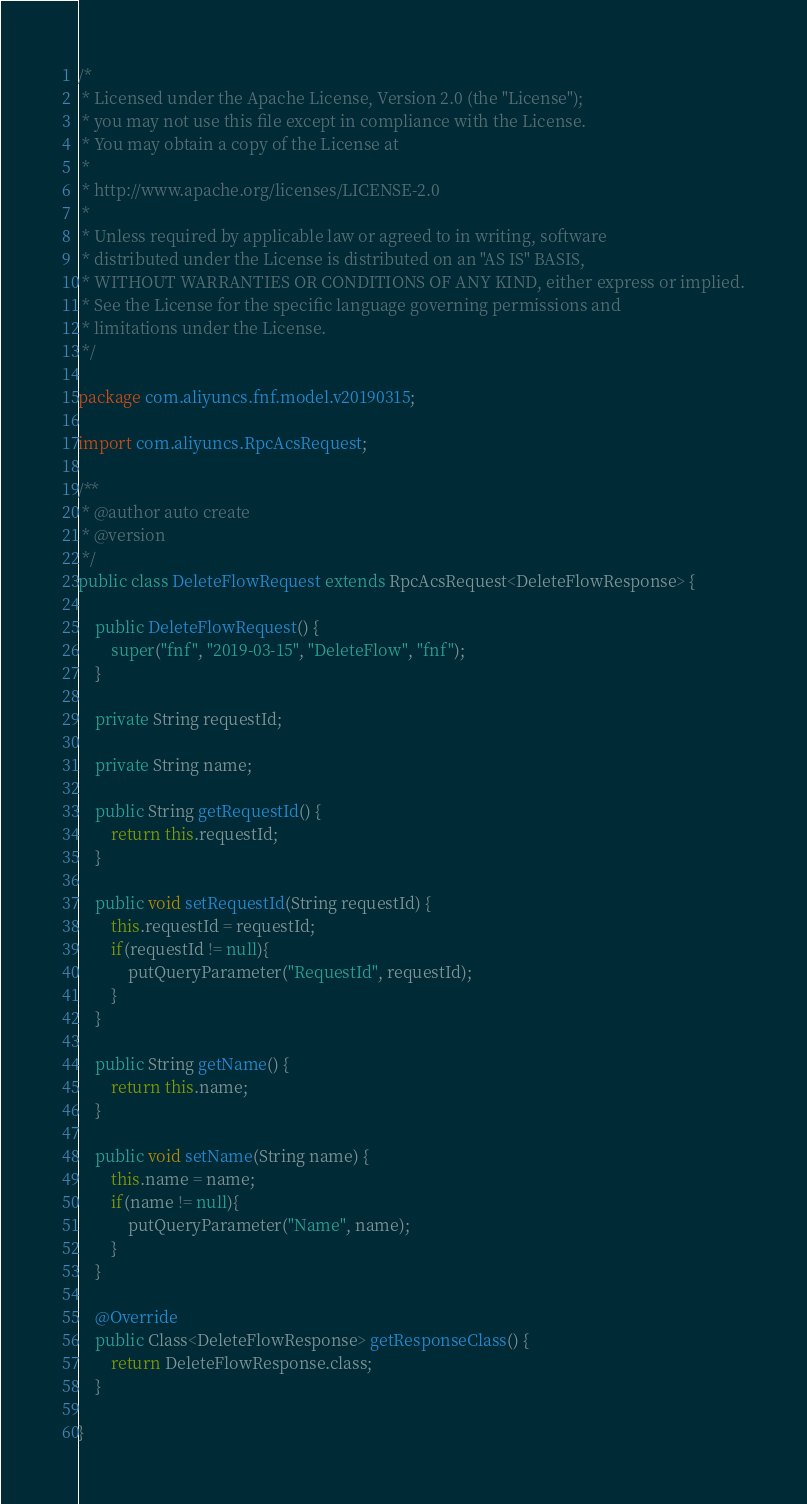Convert code to text. <code><loc_0><loc_0><loc_500><loc_500><_Java_>/*
 * Licensed under the Apache License, Version 2.0 (the "License");
 * you may not use this file except in compliance with the License.
 * You may obtain a copy of the License at
 *
 * http://www.apache.org/licenses/LICENSE-2.0
 *
 * Unless required by applicable law or agreed to in writing, software
 * distributed under the License is distributed on an "AS IS" BASIS,
 * WITHOUT WARRANTIES OR CONDITIONS OF ANY KIND, either express or implied.
 * See the License for the specific language governing permissions and
 * limitations under the License.
 */

package com.aliyuncs.fnf.model.v20190315;

import com.aliyuncs.RpcAcsRequest;

/**
 * @author auto create
 * @version 
 */
public class DeleteFlowRequest extends RpcAcsRequest<DeleteFlowResponse> {
	
	public DeleteFlowRequest() {
		super("fnf", "2019-03-15", "DeleteFlow", "fnf");
	}

	private String requestId;

	private String name;

	public String getRequestId() {
		return this.requestId;
	}

	public void setRequestId(String requestId) {
		this.requestId = requestId;
		if(requestId != null){
			putQueryParameter("RequestId", requestId);
		}
	}

	public String getName() {
		return this.name;
	}

	public void setName(String name) {
		this.name = name;
		if(name != null){
			putQueryParameter("Name", name);
		}
	}

	@Override
	public Class<DeleteFlowResponse> getResponseClass() {
		return DeleteFlowResponse.class;
	}

}
</code> 